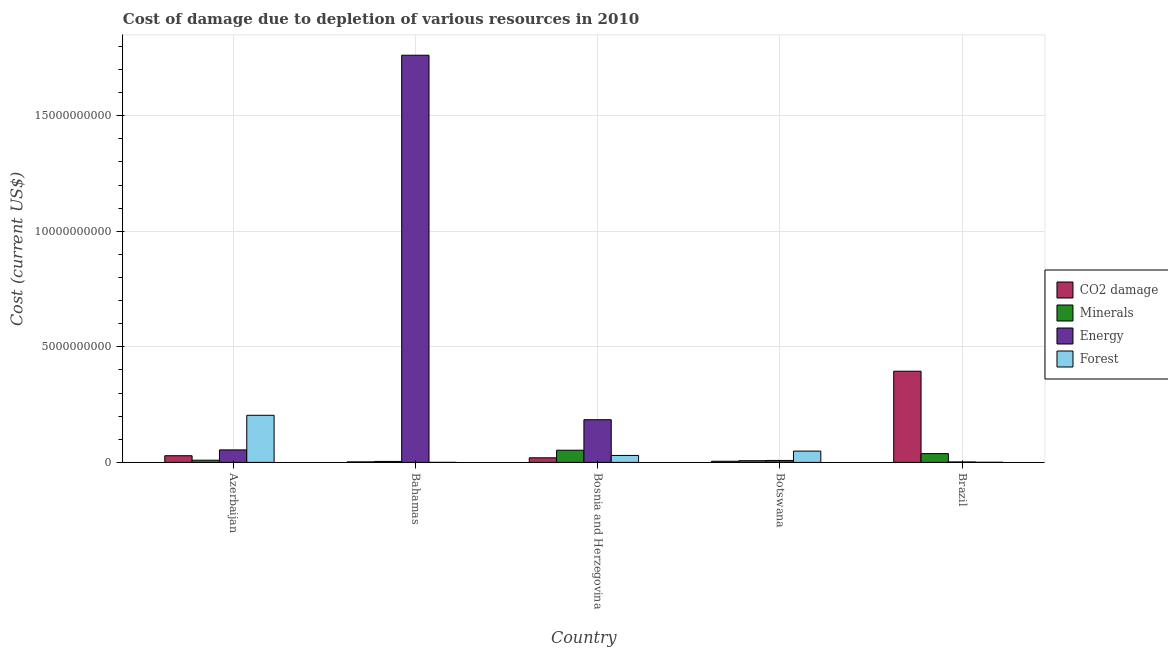How many different coloured bars are there?
Offer a very short reply. 4. How many groups of bars are there?
Ensure brevity in your answer.  5. Are the number of bars per tick equal to the number of legend labels?
Offer a terse response. Yes. How many bars are there on the 5th tick from the left?
Offer a terse response. 4. What is the label of the 4th group of bars from the left?
Your answer should be very brief. Botswana. What is the cost of damage due to depletion of energy in Botswana?
Your response must be concise. 8.42e+07. Across all countries, what is the maximum cost of damage due to depletion of forests?
Ensure brevity in your answer.  2.04e+09. Across all countries, what is the minimum cost of damage due to depletion of minerals?
Give a very brief answer. 4.21e+07. In which country was the cost of damage due to depletion of minerals maximum?
Give a very brief answer. Bosnia and Herzegovina. In which country was the cost of damage due to depletion of energy minimum?
Offer a terse response. Brazil. What is the total cost of damage due to depletion of forests in the graph?
Provide a succinct answer. 2.83e+09. What is the difference between the cost of damage due to depletion of energy in Azerbaijan and that in Botswana?
Offer a very short reply. 4.56e+08. What is the difference between the cost of damage due to depletion of forests in Bahamas and the cost of damage due to depletion of minerals in Bosnia and Herzegovina?
Make the answer very short. -5.26e+08. What is the average cost of damage due to depletion of coal per country?
Ensure brevity in your answer.  9.01e+08. What is the difference between the cost of damage due to depletion of energy and cost of damage due to depletion of minerals in Bosnia and Herzegovina?
Offer a terse response. 1.32e+09. What is the ratio of the cost of damage due to depletion of coal in Bahamas to that in Botswana?
Your response must be concise. 0.47. What is the difference between the highest and the second highest cost of damage due to depletion of forests?
Offer a terse response. 1.55e+09. What is the difference between the highest and the lowest cost of damage due to depletion of coal?
Keep it short and to the point. 3.92e+09. What does the 2nd bar from the left in Botswana represents?
Your answer should be compact. Minerals. What does the 1st bar from the right in Azerbaijan represents?
Provide a short and direct response. Forest. How many bars are there?
Ensure brevity in your answer.  20. How many countries are there in the graph?
Your answer should be compact. 5. Are the values on the major ticks of Y-axis written in scientific E-notation?
Give a very brief answer. No. Does the graph contain grids?
Provide a succinct answer. Yes. How are the legend labels stacked?
Your answer should be very brief. Vertical. What is the title of the graph?
Ensure brevity in your answer.  Cost of damage due to depletion of various resources in 2010 . Does "Other expenses" appear as one of the legend labels in the graph?
Make the answer very short. No. What is the label or title of the Y-axis?
Offer a terse response. Cost (current US$). What is the Cost (current US$) of CO2 damage in Azerbaijan?
Your response must be concise. 2.88e+08. What is the Cost (current US$) in Minerals in Azerbaijan?
Your answer should be very brief. 9.44e+07. What is the Cost (current US$) in Energy in Azerbaijan?
Offer a terse response. 5.41e+08. What is the Cost (current US$) of Forest in Azerbaijan?
Offer a very short reply. 2.04e+09. What is the Cost (current US$) of CO2 damage in Bahamas?
Ensure brevity in your answer.  2.32e+07. What is the Cost (current US$) in Minerals in Bahamas?
Your response must be concise. 4.21e+07. What is the Cost (current US$) of Energy in Bahamas?
Your answer should be very brief. 1.76e+1. What is the Cost (current US$) in Forest in Bahamas?
Provide a short and direct response. 1.32e+06. What is the Cost (current US$) of CO2 damage in Bosnia and Herzegovina?
Your answer should be compact. 1.99e+08. What is the Cost (current US$) of Minerals in Bosnia and Herzegovina?
Keep it short and to the point. 5.27e+08. What is the Cost (current US$) of Energy in Bosnia and Herzegovina?
Your answer should be very brief. 1.85e+09. What is the Cost (current US$) of Forest in Bosnia and Herzegovina?
Offer a very short reply. 3.01e+08. What is the Cost (current US$) in CO2 damage in Botswana?
Provide a short and direct response. 4.92e+07. What is the Cost (current US$) in Minerals in Botswana?
Your response must be concise. 7.36e+07. What is the Cost (current US$) of Energy in Botswana?
Provide a short and direct response. 8.42e+07. What is the Cost (current US$) in Forest in Botswana?
Ensure brevity in your answer.  4.88e+08. What is the Cost (current US$) of CO2 damage in Brazil?
Make the answer very short. 3.94e+09. What is the Cost (current US$) of Minerals in Brazil?
Offer a very short reply. 3.80e+08. What is the Cost (current US$) of Energy in Brazil?
Provide a succinct answer. 2.04e+07. What is the Cost (current US$) in Forest in Brazil?
Keep it short and to the point. 5.46e+06. Across all countries, what is the maximum Cost (current US$) of CO2 damage?
Provide a succinct answer. 3.94e+09. Across all countries, what is the maximum Cost (current US$) of Minerals?
Your answer should be compact. 5.27e+08. Across all countries, what is the maximum Cost (current US$) of Energy?
Ensure brevity in your answer.  1.76e+1. Across all countries, what is the maximum Cost (current US$) of Forest?
Offer a very short reply. 2.04e+09. Across all countries, what is the minimum Cost (current US$) in CO2 damage?
Offer a very short reply. 2.32e+07. Across all countries, what is the minimum Cost (current US$) of Minerals?
Offer a terse response. 4.21e+07. Across all countries, what is the minimum Cost (current US$) of Energy?
Your response must be concise. 2.04e+07. Across all countries, what is the minimum Cost (current US$) of Forest?
Offer a very short reply. 1.32e+06. What is the total Cost (current US$) of CO2 damage in the graph?
Keep it short and to the point. 4.50e+09. What is the total Cost (current US$) in Minerals in the graph?
Ensure brevity in your answer.  1.12e+09. What is the total Cost (current US$) of Energy in the graph?
Provide a short and direct response. 2.01e+1. What is the total Cost (current US$) of Forest in the graph?
Your answer should be very brief. 2.83e+09. What is the difference between the Cost (current US$) in CO2 damage in Azerbaijan and that in Bahamas?
Keep it short and to the point. 2.65e+08. What is the difference between the Cost (current US$) of Minerals in Azerbaijan and that in Bahamas?
Your answer should be compact. 5.23e+07. What is the difference between the Cost (current US$) in Energy in Azerbaijan and that in Bahamas?
Keep it short and to the point. -1.71e+1. What is the difference between the Cost (current US$) in Forest in Azerbaijan and that in Bahamas?
Your answer should be very brief. 2.04e+09. What is the difference between the Cost (current US$) in CO2 damage in Azerbaijan and that in Bosnia and Herzegovina?
Your response must be concise. 8.96e+07. What is the difference between the Cost (current US$) of Minerals in Azerbaijan and that in Bosnia and Herzegovina?
Give a very brief answer. -4.33e+08. What is the difference between the Cost (current US$) of Energy in Azerbaijan and that in Bosnia and Herzegovina?
Provide a short and direct response. -1.31e+09. What is the difference between the Cost (current US$) of Forest in Azerbaijan and that in Bosnia and Herzegovina?
Provide a succinct answer. 1.74e+09. What is the difference between the Cost (current US$) of CO2 damage in Azerbaijan and that in Botswana?
Keep it short and to the point. 2.39e+08. What is the difference between the Cost (current US$) of Minerals in Azerbaijan and that in Botswana?
Keep it short and to the point. 2.08e+07. What is the difference between the Cost (current US$) in Energy in Azerbaijan and that in Botswana?
Provide a succinct answer. 4.56e+08. What is the difference between the Cost (current US$) in Forest in Azerbaijan and that in Botswana?
Provide a short and direct response. 1.55e+09. What is the difference between the Cost (current US$) in CO2 damage in Azerbaijan and that in Brazil?
Make the answer very short. -3.66e+09. What is the difference between the Cost (current US$) of Minerals in Azerbaijan and that in Brazil?
Your answer should be very brief. -2.85e+08. What is the difference between the Cost (current US$) in Energy in Azerbaijan and that in Brazil?
Give a very brief answer. 5.20e+08. What is the difference between the Cost (current US$) in Forest in Azerbaijan and that in Brazil?
Ensure brevity in your answer.  2.03e+09. What is the difference between the Cost (current US$) in CO2 damage in Bahamas and that in Bosnia and Herzegovina?
Offer a very short reply. -1.76e+08. What is the difference between the Cost (current US$) in Minerals in Bahamas and that in Bosnia and Herzegovina?
Provide a succinct answer. -4.85e+08. What is the difference between the Cost (current US$) in Energy in Bahamas and that in Bosnia and Herzegovina?
Offer a very short reply. 1.58e+1. What is the difference between the Cost (current US$) of Forest in Bahamas and that in Bosnia and Herzegovina?
Your answer should be compact. -2.99e+08. What is the difference between the Cost (current US$) in CO2 damage in Bahamas and that in Botswana?
Provide a short and direct response. -2.60e+07. What is the difference between the Cost (current US$) in Minerals in Bahamas and that in Botswana?
Give a very brief answer. -3.15e+07. What is the difference between the Cost (current US$) in Energy in Bahamas and that in Botswana?
Ensure brevity in your answer.  1.75e+1. What is the difference between the Cost (current US$) of Forest in Bahamas and that in Botswana?
Your answer should be very brief. -4.87e+08. What is the difference between the Cost (current US$) of CO2 damage in Bahamas and that in Brazil?
Provide a succinct answer. -3.92e+09. What is the difference between the Cost (current US$) of Minerals in Bahamas and that in Brazil?
Offer a terse response. -3.38e+08. What is the difference between the Cost (current US$) of Energy in Bahamas and that in Brazil?
Make the answer very short. 1.76e+1. What is the difference between the Cost (current US$) in Forest in Bahamas and that in Brazil?
Offer a very short reply. -4.14e+06. What is the difference between the Cost (current US$) of CO2 damage in Bosnia and Herzegovina and that in Botswana?
Your answer should be compact. 1.50e+08. What is the difference between the Cost (current US$) in Minerals in Bosnia and Herzegovina and that in Botswana?
Your answer should be compact. 4.54e+08. What is the difference between the Cost (current US$) in Energy in Bosnia and Herzegovina and that in Botswana?
Provide a succinct answer. 1.76e+09. What is the difference between the Cost (current US$) in Forest in Bosnia and Herzegovina and that in Botswana?
Offer a very short reply. -1.88e+08. What is the difference between the Cost (current US$) in CO2 damage in Bosnia and Herzegovina and that in Brazil?
Your answer should be very brief. -3.75e+09. What is the difference between the Cost (current US$) in Minerals in Bosnia and Herzegovina and that in Brazil?
Provide a succinct answer. 1.48e+08. What is the difference between the Cost (current US$) of Energy in Bosnia and Herzegovina and that in Brazil?
Give a very brief answer. 1.83e+09. What is the difference between the Cost (current US$) in Forest in Bosnia and Herzegovina and that in Brazil?
Offer a terse response. 2.95e+08. What is the difference between the Cost (current US$) of CO2 damage in Botswana and that in Brazil?
Provide a short and direct response. -3.90e+09. What is the difference between the Cost (current US$) of Minerals in Botswana and that in Brazil?
Provide a short and direct response. -3.06e+08. What is the difference between the Cost (current US$) of Energy in Botswana and that in Brazil?
Ensure brevity in your answer.  6.38e+07. What is the difference between the Cost (current US$) in Forest in Botswana and that in Brazil?
Your answer should be very brief. 4.83e+08. What is the difference between the Cost (current US$) of CO2 damage in Azerbaijan and the Cost (current US$) of Minerals in Bahamas?
Give a very brief answer. 2.46e+08. What is the difference between the Cost (current US$) of CO2 damage in Azerbaijan and the Cost (current US$) of Energy in Bahamas?
Make the answer very short. -1.73e+1. What is the difference between the Cost (current US$) in CO2 damage in Azerbaijan and the Cost (current US$) in Forest in Bahamas?
Provide a succinct answer. 2.87e+08. What is the difference between the Cost (current US$) of Minerals in Azerbaijan and the Cost (current US$) of Energy in Bahamas?
Your response must be concise. -1.75e+1. What is the difference between the Cost (current US$) of Minerals in Azerbaijan and the Cost (current US$) of Forest in Bahamas?
Provide a short and direct response. 9.31e+07. What is the difference between the Cost (current US$) of Energy in Azerbaijan and the Cost (current US$) of Forest in Bahamas?
Your response must be concise. 5.39e+08. What is the difference between the Cost (current US$) in CO2 damage in Azerbaijan and the Cost (current US$) in Minerals in Bosnia and Herzegovina?
Ensure brevity in your answer.  -2.39e+08. What is the difference between the Cost (current US$) of CO2 damage in Azerbaijan and the Cost (current US$) of Energy in Bosnia and Herzegovina?
Ensure brevity in your answer.  -1.56e+09. What is the difference between the Cost (current US$) in CO2 damage in Azerbaijan and the Cost (current US$) in Forest in Bosnia and Herzegovina?
Your answer should be compact. -1.23e+07. What is the difference between the Cost (current US$) of Minerals in Azerbaijan and the Cost (current US$) of Energy in Bosnia and Herzegovina?
Provide a short and direct response. -1.75e+09. What is the difference between the Cost (current US$) in Minerals in Azerbaijan and the Cost (current US$) in Forest in Bosnia and Herzegovina?
Give a very brief answer. -2.06e+08. What is the difference between the Cost (current US$) of Energy in Azerbaijan and the Cost (current US$) of Forest in Bosnia and Herzegovina?
Provide a short and direct response. 2.40e+08. What is the difference between the Cost (current US$) in CO2 damage in Azerbaijan and the Cost (current US$) in Minerals in Botswana?
Your answer should be compact. 2.15e+08. What is the difference between the Cost (current US$) in CO2 damage in Azerbaijan and the Cost (current US$) in Energy in Botswana?
Provide a succinct answer. 2.04e+08. What is the difference between the Cost (current US$) of CO2 damage in Azerbaijan and the Cost (current US$) of Forest in Botswana?
Your response must be concise. -2.00e+08. What is the difference between the Cost (current US$) of Minerals in Azerbaijan and the Cost (current US$) of Energy in Botswana?
Give a very brief answer. 1.02e+07. What is the difference between the Cost (current US$) of Minerals in Azerbaijan and the Cost (current US$) of Forest in Botswana?
Keep it short and to the point. -3.94e+08. What is the difference between the Cost (current US$) of Energy in Azerbaijan and the Cost (current US$) of Forest in Botswana?
Make the answer very short. 5.21e+07. What is the difference between the Cost (current US$) of CO2 damage in Azerbaijan and the Cost (current US$) of Minerals in Brazil?
Ensure brevity in your answer.  -9.13e+07. What is the difference between the Cost (current US$) of CO2 damage in Azerbaijan and the Cost (current US$) of Energy in Brazil?
Provide a succinct answer. 2.68e+08. What is the difference between the Cost (current US$) of CO2 damage in Azerbaijan and the Cost (current US$) of Forest in Brazil?
Provide a short and direct response. 2.83e+08. What is the difference between the Cost (current US$) in Minerals in Azerbaijan and the Cost (current US$) in Energy in Brazil?
Ensure brevity in your answer.  7.40e+07. What is the difference between the Cost (current US$) of Minerals in Azerbaijan and the Cost (current US$) of Forest in Brazil?
Offer a very short reply. 8.89e+07. What is the difference between the Cost (current US$) in Energy in Azerbaijan and the Cost (current US$) in Forest in Brazil?
Provide a succinct answer. 5.35e+08. What is the difference between the Cost (current US$) in CO2 damage in Bahamas and the Cost (current US$) in Minerals in Bosnia and Herzegovina?
Offer a terse response. -5.04e+08. What is the difference between the Cost (current US$) of CO2 damage in Bahamas and the Cost (current US$) of Energy in Bosnia and Herzegovina?
Provide a succinct answer. -1.82e+09. What is the difference between the Cost (current US$) of CO2 damage in Bahamas and the Cost (current US$) of Forest in Bosnia and Herzegovina?
Provide a short and direct response. -2.77e+08. What is the difference between the Cost (current US$) of Minerals in Bahamas and the Cost (current US$) of Energy in Bosnia and Herzegovina?
Provide a short and direct response. -1.80e+09. What is the difference between the Cost (current US$) of Minerals in Bahamas and the Cost (current US$) of Forest in Bosnia and Herzegovina?
Provide a succinct answer. -2.59e+08. What is the difference between the Cost (current US$) of Energy in Bahamas and the Cost (current US$) of Forest in Bosnia and Herzegovina?
Your response must be concise. 1.73e+1. What is the difference between the Cost (current US$) in CO2 damage in Bahamas and the Cost (current US$) in Minerals in Botswana?
Your answer should be compact. -5.04e+07. What is the difference between the Cost (current US$) in CO2 damage in Bahamas and the Cost (current US$) in Energy in Botswana?
Provide a succinct answer. -6.10e+07. What is the difference between the Cost (current US$) in CO2 damage in Bahamas and the Cost (current US$) in Forest in Botswana?
Your answer should be very brief. -4.65e+08. What is the difference between the Cost (current US$) in Minerals in Bahamas and the Cost (current US$) in Energy in Botswana?
Provide a short and direct response. -4.20e+07. What is the difference between the Cost (current US$) of Minerals in Bahamas and the Cost (current US$) of Forest in Botswana?
Provide a succinct answer. -4.46e+08. What is the difference between the Cost (current US$) of Energy in Bahamas and the Cost (current US$) of Forest in Botswana?
Make the answer very short. 1.71e+1. What is the difference between the Cost (current US$) in CO2 damage in Bahamas and the Cost (current US$) in Minerals in Brazil?
Make the answer very short. -3.56e+08. What is the difference between the Cost (current US$) of CO2 damage in Bahamas and the Cost (current US$) of Energy in Brazil?
Provide a succinct answer. 2.80e+06. What is the difference between the Cost (current US$) of CO2 damage in Bahamas and the Cost (current US$) of Forest in Brazil?
Provide a short and direct response. 1.77e+07. What is the difference between the Cost (current US$) of Minerals in Bahamas and the Cost (current US$) of Energy in Brazil?
Keep it short and to the point. 2.18e+07. What is the difference between the Cost (current US$) in Minerals in Bahamas and the Cost (current US$) in Forest in Brazil?
Give a very brief answer. 3.67e+07. What is the difference between the Cost (current US$) in Energy in Bahamas and the Cost (current US$) in Forest in Brazil?
Your answer should be compact. 1.76e+1. What is the difference between the Cost (current US$) of CO2 damage in Bosnia and Herzegovina and the Cost (current US$) of Minerals in Botswana?
Ensure brevity in your answer.  1.25e+08. What is the difference between the Cost (current US$) of CO2 damage in Bosnia and Herzegovina and the Cost (current US$) of Energy in Botswana?
Provide a succinct answer. 1.15e+08. What is the difference between the Cost (current US$) of CO2 damage in Bosnia and Herzegovina and the Cost (current US$) of Forest in Botswana?
Keep it short and to the point. -2.90e+08. What is the difference between the Cost (current US$) of Minerals in Bosnia and Herzegovina and the Cost (current US$) of Energy in Botswana?
Your answer should be very brief. 4.43e+08. What is the difference between the Cost (current US$) in Minerals in Bosnia and Herzegovina and the Cost (current US$) in Forest in Botswana?
Offer a terse response. 3.91e+07. What is the difference between the Cost (current US$) of Energy in Bosnia and Herzegovina and the Cost (current US$) of Forest in Botswana?
Provide a succinct answer. 1.36e+09. What is the difference between the Cost (current US$) in CO2 damage in Bosnia and Herzegovina and the Cost (current US$) in Minerals in Brazil?
Your answer should be compact. -1.81e+08. What is the difference between the Cost (current US$) of CO2 damage in Bosnia and Herzegovina and the Cost (current US$) of Energy in Brazil?
Your response must be concise. 1.78e+08. What is the difference between the Cost (current US$) in CO2 damage in Bosnia and Herzegovina and the Cost (current US$) in Forest in Brazil?
Provide a short and direct response. 1.93e+08. What is the difference between the Cost (current US$) of Minerals in Bosnia and Herzegovina and the Cost (current US$) of Energy in Brazil?
Offer a very short reply. 5.07e+08. What is the difference between the Cost (current US$) of Minerals in Bosnia and Herzegovina and the Cost (current US$) of Forest in Brazil?
Your answer should be compact. 5.22e+08. What is the difference between the Cost (current US$) in Energy in Bosnia and Herzegovina and the Cost (current US$) in Forest in Brazil?
Keep it short and to the point. 1.84e+09. What is the difference between the Cost (current US$) in CO2 damage in Botswana and the Cost (current US$) in Minerals in Brazil?
Provide a succinct answer. -3.30e+08. What is the difference between the Cost (current US$) in CO2 damage in Botswana and the Cost (current US$) in Energy in Brazil?
Make the answer very short. 2.88e+07. What is the difference between the Cost (current US$) in CO2 damage in Botswana and the Cost (current US$) in Forest in Brazil?
Provide a succinct answer. 4.37e+07. What is the difference between the Cost (current US$) of Minerals in Botswana and the Cost (current US$) of Energy in Brazil?
Give a very brief answer. 5.32e+07. What is the difference between the Cost (current US$) in Minerals in Botswana and the Cost (current US$) in Forest in Brazil?
Make the answer very short. 6.81e+07. What is the difference between the Cost (current US$) in Energy in Botswana and the Cost (current US$) in Forest in Brazil?
Give a very brief answer. 7.87e+07. What is the average Cost (current US$) in CO2 damage per country?
Your answer should be very brief. 9.01e+08. What is the average Cost (current US$) in Minerals per country?
Give a very brief answer. 2.23e+08. What is the average Cost (current US$) in Energy per country?
Keep it short and to the point. 4.02e+09. What is the average Cost (current US$) in Forest per country?
Your answer should be compact. 5.67e+08. What is the difference between the Cost (current US$) of CO2 damage and Cost (current US$) of Minerals in Azerbaijan?
Ensure brevity in your answer.  1.94e+08. What is the difference between the Cost (current US$) in CO2 damage and Cost (current US$) in Energy in Azerbaijan?
Keep it short and to the point. -2.52e+08. What is the difference between the Cost (current US$) in CO2 damage and Cost (current US$) in Forest in Azerbaijan?
Give a very brief answer. -1.75e+09. What is the difference between the Cost (current US$) in Minerals and Cost (current US$) in Energy in Azerbaijan?
Your answer should be very brief. -4.46e+08. What is the difference between the Cost (current US$) of Minerals and Cost (current US$) of Forest in Azerbaijan?
Make the answer very short. -1.94e+09. What is the difference between the Cost (current US$) in Energy and Cost (current US$) in Forest in Azerbaijan?
Make the answer very short. -1.50e+09. What is the difference between the Cost (current US$) in CO2 damage and Cost (current US$) in Minerals in Bahamas?
Provide a succinct answer. -1.90e+07. What is the difference between the Cost (current US$) of CO2 damage and Cost (current US$) of Energy in Bahamas?
Your answer should be very brief. -1.76e+1. What is the difference between the Cost (current US$) of CO2 damage and Cost (current US$) of Forest in Bahamas?
Offer a terse response. 2.18e+07. What is the difference between the Cost (current US$) of Minerals and Cost (current US$) of Energy in Bahamas?
Your answer should be very brief. -1.76e+1. What is the difference between the Cost (current US$) in Minerals and Cost (current US$) in Forest in Bahamas?
Your answer should be very brief. 4.08e+07. What is the difference between the Cost (current US$) in Energy and Cost (current US$) in Forest in Bahamas?
Ensure brevity in your answer.  1.76e+1. What is the difference between the Cost (current US$) in CO2 damage and Cost (current US$) in Minerals in Bosnia and Herzegovina?
Keep it short and to the point. -3.29e+08. What is the difference between the Cost (current US$) in CO2 damage and Cost (current US$) in Energy in Bosnia and Herzegovina?
Your answer should be compact. -1.65e+09. What is the difference between the Cost (current US$) of CO2 damage and Cost (current US$) of Forest in Bosnia and Herzegovina?
Offer a terse response. -1.02e+08. What is the difference between the Cost (current US$) in Minerals and Cost (current US$) in Energy in Bosnia and Herzegovina?
Ensure brevity in your answer.  -1.32e+09. What is the difference between the Cost (current US$) of Minerals and Cost (current US$) of Forest in Bosnia and Herzegovina?
Offer a very short reply. 2.27e+08. What is the difference between the Cost (current US$) of Energy and Cost (current US$) of Forest in Bosnia and Herzegovina?
Make the answer very short. 1.55e+09. What is the difference between the Cost (current US$) in CO2 damage and Cost (current US$) in Minerals in Botswana?
Provide a short and direct response. -2.44e+07. What is the difference between the Cost (current US$) in CO2 damage and Cost (current US$) in Energy in Botswana?
Your response must be concise. -3.50e+07. What is the difference between the Cost (current US$) in CO2 damage and Cost (current US$) in Forest in Botswana?
Your answer should be very brief. -4.39e+08. What is the difference between the Cost (current US$) in Minerals and Cost (current US$) in Energy in Botswana?
Ensure brevity in your answer.  -1.06e+07. What is the difference between the Cost (current US$) of Minerals and Cost (current US$) of Forest in Botswana?
Keep it short and to the point. -4.15e+08. What is the difference between the Cost (current US$) of Energy and Cost (current US$) of Forest in Botswana?
Your answer should be very brief. -4.04e+08. What is the difference between the Cost (current US$) in CO2 damage and Cost (current US$) in Minerals in Brazil?
Make the answer very short. 3.57e+09. What is the difference between the Cost (current US$) in CO2 damage and Cost (current US$) in Energy in Brazil?
Your answer should be very brief. 3.92e+09. What is the difference between the Cost (current US$) in CO2 damage and Cost (current US$) in Forest in Brazil?
Make the answer very short. 3.94e+09. What is the difference between the Cost (current US$) in Minerals and Cost (current US$) in Energy in Brazil?
Give a very brief answer. 3.59e+08. What is the difference between the Cost (current US$) of Minerals and Cost (current US$) of Forest in Brazil?
Offer a terse response. 3.74e+08. What is the difference between the Cost (current US$) in Energy and Cost (current US$) in Forest in Brazil?
Keep it short and to the point. 1.49e+07. What is the ratio of the Cost (current US$) of CO2 damage in Azerbaijan to that in Bahamas?
Ensure brevity in your answer.  12.45. What is the ratio of the Cost (current US$) of Minerals in Azerbaijan to that in Bahamas?
Keep it short and to the point. 2.24. What is the ratio of the Cost (current US$) in Energy in Azerbaijan to that in Bahamas?
Offer a very short reply. 0.03. What is the ratio of the Cost (current US$) of Forest in Azerbaijan to that in Bahamas?
Provide a short and direct response. 1541.49. What is the ratio of the Cost (current US$) of CO2 damage in Azerbaijan to that in Bosnia and Herzegovina?
Give a very brief answer. 1.45. What is the ratio of the Cost (current US$) of Minerals in Azerbaijan to that in Bosnia and Herzegovina?
Your answer should be very brief. 0.18. What is the ratio of the Cost (current US$) of Energy in Azerbaijan to that in Bosnia and Herzegovina?
Offer a terse response. 0.29. What is the ratio of the Cost (current US$) in Forest in Azerbaijan to that in Bosnia and Herzegovina?
Your answer should be very brief. 6.78. What is the ratio of the Cost (current US$) in CO2 damage in Azerbaijan to that in Botswana?
Keep it short and to the point. 5.86. What is the ratio of the Cost (current US$) of Minerals in Azerbaijan to that in Botswana?
Your answer should be very brief. 1.28. What is the ratio of the Cost (current US$) in Energy in Azerbaijan to that in Botswana?
Give a very brief answer. 6.42. What is the ratio of the Cost (current US$) in Forest in Azerbaijan to that in Botswana?
Offer a very short reply. 4.17. What is the ratio of the Cost (current US$) in CO2 damage in Azerbaijan to that in Brazil?
Offer a terse response. 0.07. What is the ratio of the Cost (current US$) of Minerals in Azerbaijan to that in Brazil?
Your answer should be compact. 0.25. What is the ratio of the Cost (current US$) in Energy in Azerbaijan to that in Brazil?
Give a very brief answer. 26.55. What is the ratio of the Cost (current US$) in Forest in Azerbaijan to that in Brazil?
Offer a terse response. 372.93. What is the ratio of the Cost (current US$) of CO2 damage in Bahamas to that in Bosnia and Herzegovina?
Make the answer very short. 0.12. What is the ratio of the Cost (current US$) in Minerals in Bahamas to that in Bosnia and Herzegovina?
Provide a short and direct response. 0.08. What is the ratio of the Cost (current US$) of Energy in Bahamas to that in Bosnia and Herzegovina?
Offer a terse response. 9.54. What is the ratio of the Cost (current US$) of Forest in Bahamas to that in Bosnia and Herzegovina?
Keep it short and to the point. 0. What is the ratio of the Cost (current US$) of CO2 damage in Bahamas to that in Botswana?
Ensure brevity in your answer.  0.47. What is the ratio of the Cost (current US$) in Minerals in Bahamas to that in Botswana?
Give a very brief answer. 0.57. What is the ratio of the Cost (current US$) of Energy in Bahamas to that in Botswana?
Provide a short and direct response. 209.3. What is the ratio of the Cost (current US$) of Forest in Bahamas to that in Botswana?
Provide a succinct answer. 0. What is the ratio of the Cost (current US$) in CO2 damage in Bahamas to that in Brazil?
Your response must be concise. 0.01. What is the ratio of the Cost (current US$) in Minerals in Bahamas to that in Brazil?
Offer a very short reply. 0.11. What is the ratio of the Cost (current US$) of Energy in Bahamas to that in Brazil?
Your response must be concise. 865.36. What is the ratio of the Cost (current US$) of Forest in Bahamas to that in Brazil?
Offer a very short reply. 0.24. What is the ratio of the Cost (current US$) in CO2 damage in Bosnia and Herzegovina to that in Botswana?
Provide a succinct answer. 4.04. What is the ratio of the Cost (current US$) in Minerals in Bosnia and Herzegovina to that in Botswana?
Give a very brief answer. 7.17. What is the ratio of the Cost (current US$) of Energy in Bosnia and Herzegovina to that in Botswana?
Provide a succinct answer. 21.94. What is the ratio of the Cost (current US$) in Forest in Bosnia and Herzegovina to that in Botswana?
Your response must be concise. 0.62. What is the ratio of the Cost (current US$) in CO2 damage in Bosnia and Herzegovina to that in Brazil?
Ensure brevity in your answer.  0.05. What is the ratio of the Cost (current US$) in Minerals in Bosnia and Herzegovina to that in Brazil?
Offer a very short reply. 1.39. What is the ratio of the Cost (current US$) in Energy in Bosnia and Herzegovina to that in Brazil?
Offer a very short reply. 90.73. What is the ratio of the Cost (current US$) of Forest in Bosnia and Herzegovina to that in Brazil?
Keep it short and to the point. 55.02. What is the ratio of the Cost (current US$) of CO2 damage in Botswana to that in Brazil?
Keep it short and to the point. 0.01. What is the ratio of the Cost (current US$) of Minerals in Botswana to that in Brazil?
Offer a terse response. 0.19. What is the ratio of the Cost (current US$) in Energy in Botswana to that in Brazil?
Offer a very short reply. 4.13. What is the ratio of the Cost (current US$) of Forest in Botswana to that in Brazil?
Provide a short and direct response. 89.38. What is the difference between the highest and the second highest Cost (current US$) in CO2 damage?
Offer a very short reply. 3.66e+09. What is the difference between the highest and the second highest Cost (current US$) in Minerals?
Keep it short and to the point. 1.48e+08. What is the difference between the highest and the second highest Cost (current US$) in Energy?
Your answer should be compact. 1.58e+1. What is the difference between the highest and the second highest Cost (current US$) of Forest?
Provide a succinct answer. 1.55e+09. What is the difference between the highest and the lowest Cost (current US$) of CO2 damage?
Your response must be concise. 3.92e+09. What is the difference between the highest and the lowest Cost (current US$) of Minerals?
Keep it short and to the point. 4.85e+08. What is the difference between the highest and the lowest Cost (current US$) in Energy?
Provide a succinct answer. 1.76e+1. What is the difference between the highest and the lowest Cost (current US$) in Forest?
Ensure brevity in your answer.  2.04e+09. 